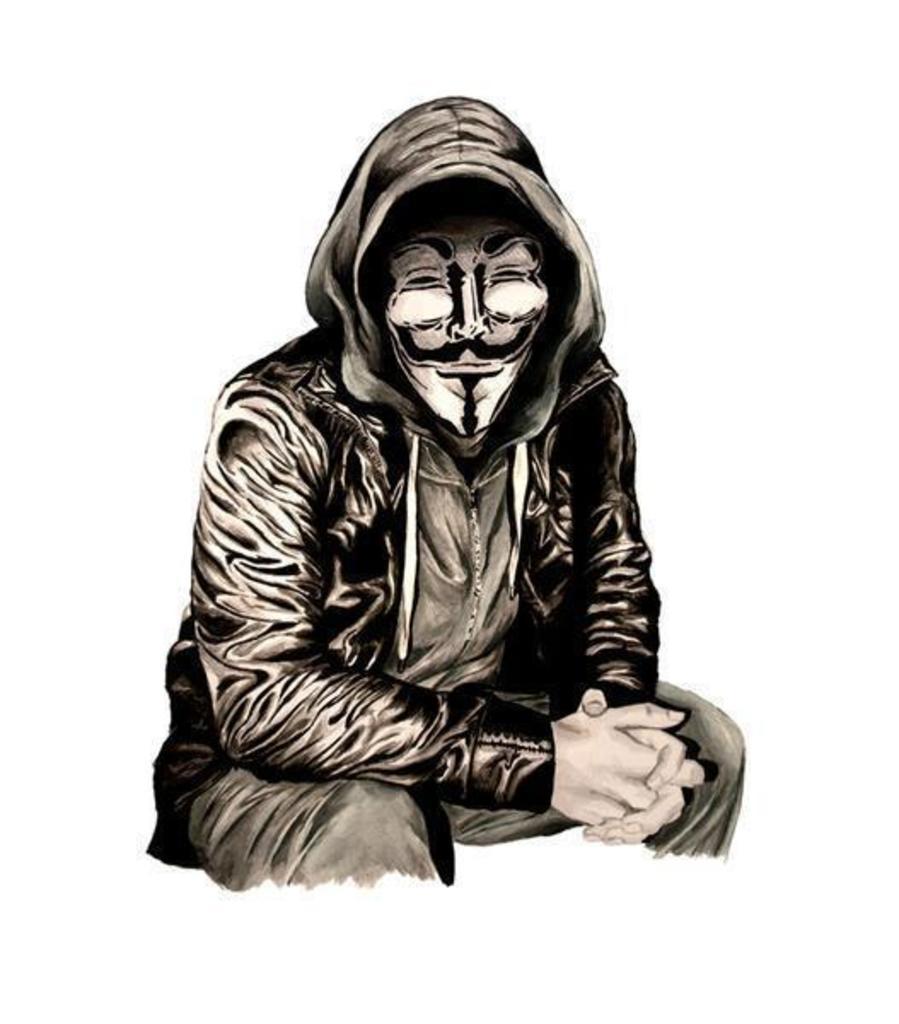Please provide a concise description of this image. In this image I can see the painting of the person in black and white color. Background is in white color. 